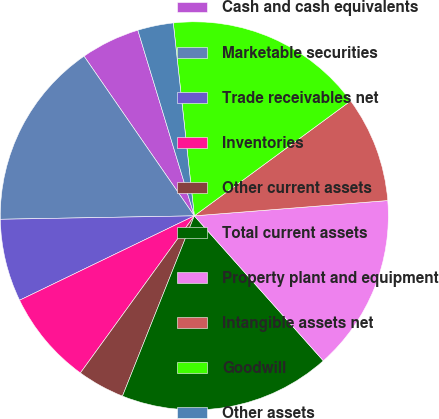<chart> <loc_0><loc_0><loc_500><loc_500><pie_chart><fcel>Cash and cash equivalents<fcel>Marketable securities<fcel>Trade receivables net<fcel>Inventories<fcel>Other current assets<fcel>Total current assets<fcel>Property plant and equipment<fcel>Intangible assets net<fcel>Goodwill<fcel>Other assets<nl><fcel>4.92%<fcel>15.66%<fcel>6.88%<fcel>7.85%<fcel>3.95%<fcel>17.61%<fcel>14.68%<fcel>8.83%<fcel>16.64%<fcel>2.97%<nl></chart> 